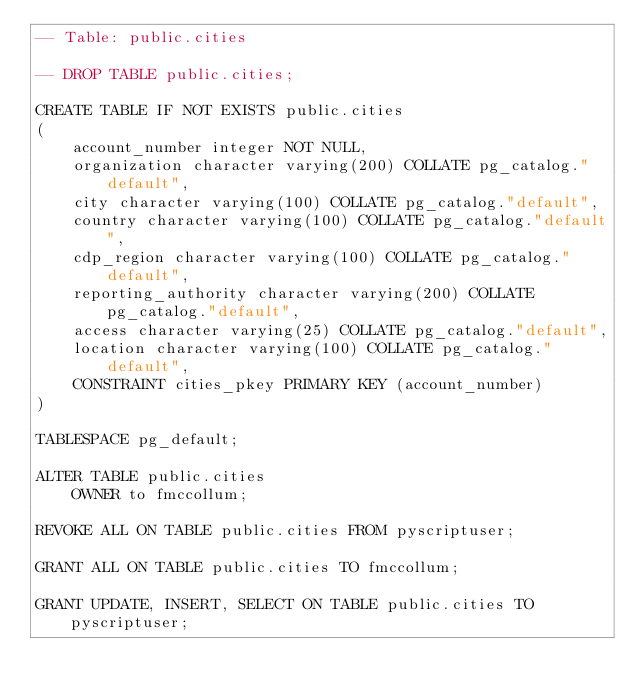Convert code to text. <code><loc_0><loc_0><loc_500><loc_500><_SQL_>-- Table: public.cities

-- DROP TABLE public.cities;

CREATE TABLE IF NOT EXISTS public.cities
(
    account_number integer NOT NULL,
    organization character varying(200) COLLATE pg_catalog."default",
    city character varying(100) COLLATE pg_catalog."default",
    country character varying(100) COLLATE pg_catalog."default",
    cdp_region character varying(100) COLLATE pg_catalog."default",
    reporting_authority character varying(200) COLLATE pg_catalog."default",
    access character varying(25) COLLATE pg_catalog."default",
    location character varying(100) COLLATE pg_catalog."default",
    CONSTRAINT cities_pkey PRIMARY KEY (account_number)
)

TABLESPACE pg_default;

ALTER TABLE public.cities
    OWNER to fmccollum;

REVOKE ALL ON TABLE public.cities FROM pyscriptuser;

GRANT ALL ON TABLE public.cities TO fmccollum;

GRANT UPDATE, INSERT, SELECT ON TABLE public.cities TO pyscriptuser;</code> 